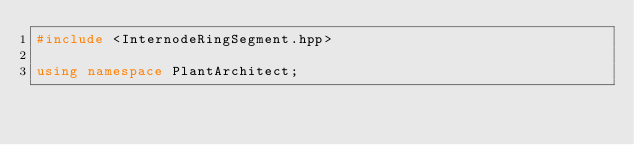<code> <loc_0><loc_0><loc_500><loc_500><_C++_>#include <InternodeRingSegment.hpp>

using namespace PlantArchitect;
</code> 